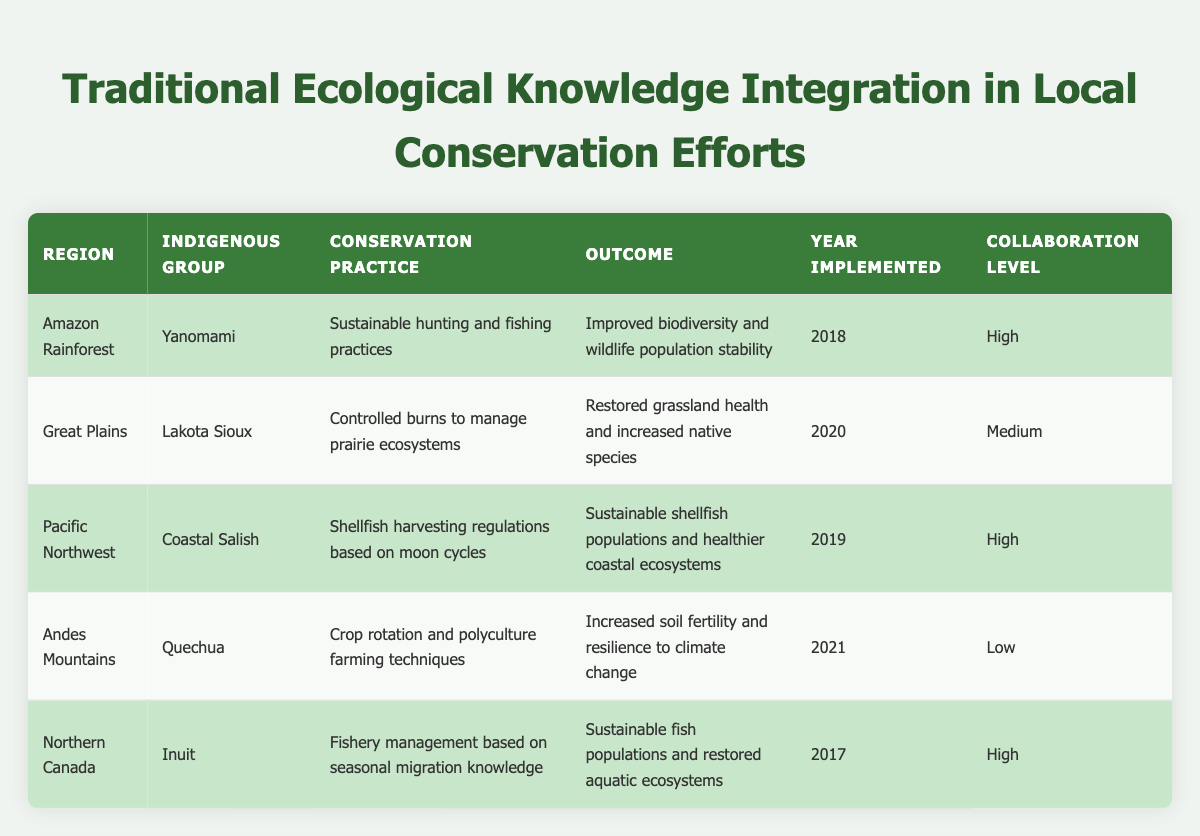What is the conservation practice implemented by the Yanomami in the Amazon Rainforest? The table lists the conservation practices for each indigenous group. In the row for the Yanomami in the Amazon Rainforest, the conservation practice is documented as "Sustainable hunting and fishing practices."
Answer: Sustainable hunting and fishing practices Which indigenous group uses controlled burns in the Great Plains? The row for the Great Plains indicates that the indigenous group practicing controlled burns is the Lakota Sioux, as specified under the "Indigenous Group" column.
Answer: Lakota Sioux How many conservation practices have a high collaboration level? The table can be filtered to identify rows with a "High" collaboration level, which includes the Yanomami, Coastal Salish, and Inuit. Therefore, there are three conservation practices with a high collaboration level.
Answer: 3 Is the outcome of the conservation practice by the Quechua in 2021 "Sustainable shellfish populations and healthier coastal ecosystems"? Checking the table, the outcome for the Quechua is documented as "Increased soil fertility and resilience to climate change," not the one mentioned in the question. Therefore, the statement is false.
Answer: No What is the average year of implementation for the conservation practices listed? The years of implementation are 2018, 2020, 2019, 2021, and 2017. Adding these gives a total of 2018 + 2020 + 2019 + 2021 + 2017 = 10095. Dividing by 5 (the number of practices) gives an average year of 2019.
Answer: 2019 Which region has the highest collaboration level, and what is the conservation practice associated with it? Filtering through the table for the highest collaboration level, "High," reveals three regions: Amazon Rainforest (Sustainable hunting and fishing practices), Pacific Northwest (Shellfish harvesting regulations based on moon cycles), and Northern Canada (Fishery management based on seasonal migration knowledge). All three regions can be classified as having high collaboration levels.
Answer: Amazon Rainforest has sustainable hunting and fishing practices What is the difference in outcomes for conservation practices between those with high collaboration and those with low collaboration? The outcomes for high collaboration practices are "Improved biodiversity and wildlife population stability," "Sustainable shellfish populations and healthier coastal ecosystems," and "Sustainable fish populations and restored aquatic ecosystems," while for the low collaboration practice, the outcome is "Increased soil fertility and resilience to climate change." The outcomes with high collaboration involve directly sustaining biodiversity, whereas the low collaboration outcome focuses on soil fertility. Hence, the difference lies in the focus on biodiversity vs. soil health.
Answer: Biodiversity vs. soil health How does the year of implementation of the conservation practice compare between the Quechua and the Lakota Sioux? The Quechua implemented their conservation practice in 2021, while the Lakota Sioux implemented theirs in 2020. Thus, the Quechua implemented their practice one year later than the Lakota Sioux.
Answer: Quechua implemented one year later Which indigenous group focuses on fishery management in Northern Canada? The table specifies the indigenous group associated with fishery management in Northern Canada is the Inuit, as noted in the relevant row.
Answer: Inuit 